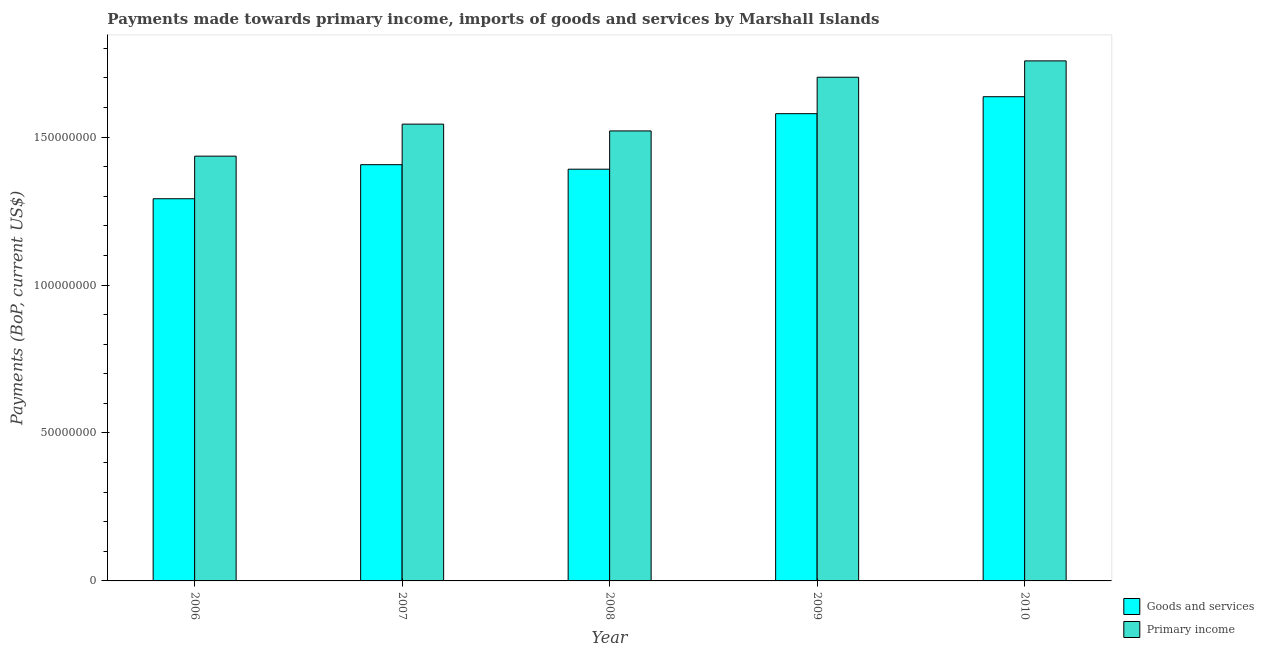How many different coloured bars are there?
Give a very brief answer. 2. How many groups of bars are there?
Ensure brevity in your answer.  5. Are the number of bars per tick equal to the number of legend labels?
Your answer should be compact. Yes. Are the number of bars on each tick of the X-axis equal?
Ensure brevity in your answer.  Yes. How many bars are there on the 1st tick from the left?
Provide a short and direct response. 2. How many bars are there on the 2nd tick from the right?
Your response must be concise. 2. What is the label of the 4th group of bars from the left?
Ensure brevity in your answer.  2009. In how many cases, is the number of bars for a given year not equal to the number of legend labels?
Your response must be concise. 0. What is the payments made towards primary income in 2007?
Offer a very short reply. 1.54e+08. Across all years, what is the maximum payments made towards goods and services?
Provide a short and direct response. 1.64e+08. Across all years, what is the minimum payments made towards goods and services?
Ensure brevity in your answer.  1.29e+08. In which year was the payments made towards goods and services maximum?
Offer a terse response. 2010. What is the total payments made towards goods and services in the graph?
Ensure brevity in your answer.  7.31e+08. What is the difference between the payments made towards goods and services in 2006 and that in 2010?
Ensure brevity in your answer.  -3.45e+07. What is the difference between the payments made towards goods and services in 2009 and the payments made towards primary income in 2008?
Your response must be concise. 1.88e+07. What is the average payments made towards primary income per year?
Provide a short and direct response. 1.59e+08. In the year 2007, what is the difference between the payments made towards goods and services and payments made towards primary income?
Your answer should be very brief. 0. In how many years, is the payments made towards goods and services greater than 40000000 US$?
Make the answer very short. 5. What is the ratio of the payments made towards primary income in 2008 to that in 2009?
Make the answer very short. 0.89. Is the payments made towards goods and services in 2006 less than that in 2010?
Your answer should be compact. Yes. Is the difference between the payments made towards goods and services in 2007 and 2010 greater than the difference between the payments made towards primary income in 2007 and 2010?
Provide a short and direct response. No. What is the difference between the highest and the second highest payments made towards goods and services?
Provide a succinct answer. 5.73e+06. What is the difference between the highest and the lowest payments made towards goods and services?
Provide a succinct answer. 3.45e+07. What does the 2nd bar from the left in 2006 represents?
Make the answer very short. Primary income. What does the 2nd bar from the right in 2008 represents?
Your response must be concise. Goods and services. How many bars are there?
Your response must be concise. 10. How many years are there in the graph?
Your response must be concise. 5. What is the difference between two consecutive major ticks on the Y-axis?
Your answer should be very brief. 5.00e+07. Are the values on the major ticks of Y-axis written in scientific E-notation?
Your response must be concise. No. Does the graph contain grids?
Ensure brevity in your answer.  No. How many legend labels are there?
Make the answer very short. 2. What is the title of the graph?
Offer a terse response. Payments made towards primary income, imports of goods and services by Marshall Islands. Does "Taxes on exports" appear as one of the legend labels in the graph?
Provide a short and direct response. No. What is the label or title of the Y-axis?
Your answer should be very brief. Payments (BoP, current US$). What is the Payments (BoP, current US$) in Goods and services in 2006?
Your response must be concise. 1.29e+08. What is the Payments (BoP, current US$) in Primary income in 2006?
Keep it short and to the point. 1.44e+08. What is the Payments (BoP, current US$) in Goods and services in 2007?
Your response must be concise. 1.41e+08. What is the Payments (BoP, current US$) of Primary income in 2007?
Keep it short and to the point. 1.54e+08. What is the Payments (BoP, current US$) in Goods and services in 2008?
Ensure brevity in your answer.  1.39e+08. What is the Payments (BoP, current US$) in Primary income in 2008?
Ensure brevity in your answer.  1.52e+08. What is the Payments (BoP, current US$) of Goods and services in 2009?
Your answer should be compact. 1.58e+08. What is the Payments (BoP, current US$) in Primary income in 2009?
Provide a succinct answer. 1.70e+08. What is the Payments (BoP, current US$) of Goods and services in 2010?
Ensure brevity in your answer.  1.64e+08. What is the Payments (BoP, current US$) in Primary income in 2010?
Your response must be concise. 1.76e+08. Across all years, what is the maximum Payments (BoP, current US$) of Goods and services?
Your answer should be compact. 1.64e+08. Across all years, what is the maximum Payments (BoP, current US$) of Primary income?
Make the answer very short. 1.76e+08. Across all years, what is the minimum Payments (BoP, current US$) of Goods and services?
Ensure brevity in your answer.  1.29e+08. Across all years, what is the minimum Payments (BoP, current US$) in Primary income?
Offer a very short reply. 1.44e+08. What is the total Payments (BoP, current US$) of Goods and services in the graph?
Give a very brief answer. 7.31e+08. What is the total Payments (BoP, current US$) in Primary income in the graph?
Make the answer very short. 7.96e+08. What is the difference between the Payments (BoP, current US$) in Goods and services in 2006 and that in 2007?
Keep it short and to the point. -1.15e+07. What is the difference between the Payments (BoP, current US$) of Primary income in 2006 and that in 2007?
Provide a succinct answer. -1.08e+07. What is the difference between the Payments (BoP, current US$) in Goods and services in 2006 and that in 2008?
Your response must be concise. -9.99e+06. What is the difference between the Payments (BoP, current US$) of Primary income in 2006 and that in 2008?
Your answer should be very brief. -8.53e+06. What is the difference between the Payments (BoP, current US$) in Goods and services in 2006 and that in 2009?
Your answer should be compact. -2.88e+07. What is the difference between the Payments (BoP, current US$) in Primary income in 2006 and that in 2009?
Provide a succinct answer. -2.67e+07. What is the difference between the Payments (BoP, current US$) in Goods and services in 2006 and that in 2010?
Offer a terse response. -3.45e+07. What is the difference between the Payments (BoP, current US$) in Primary income in 2006 and that in 2010?
Give a very brief answer. -3.22e+07. What is the difference between the Payments (BoP, current US$) in Goods and services in 2007 and that in 2008?
Provide a succinct answer. 1.53e+06. What is the difference between the Payments (BoP, current US$) in Primary income in 2007 and that in 2008?
Keep it short and to the point. 2.30e+06. What is the difference between the Payments (BoP, current US$) in Goods and services in 2007 and that in 2009?
Provide a short and direct response. -1.72e+07. What is the difference between the Payments (BoP, current US$) in Primary income in 2007 and that in 2009?
Your response must be concise. -1.59e+07. What is the difference between the Payments (BoP, current US$) of Goods and services in 2007 and that in 2010?
Ensure brevity in your answer.  -2.30e+07. What is the difference between the Payments (BoP, current US$) of Primary income in 2007 and that in 2010?
Provide a succinct answer. -2.14e+07. What is the difference between the Payments (BoP, current US$) of Goods and services in 2008 and that in 2009?
Your response must be concise. -1.88e+07. What is the difference between the Payments (BoP, current US$) in Primary income in 2008 and that in 2009?
Provide a short and direct response. -1.81e+07. What is the difference between the Payments (BoP, current US$) in Goods and services in 2008 and that in 2010?
Offer a terse response. -2.45e+07. What is the difference between the Payments (BoP, current US$) of Primary income in 2008 and that in 2010?
Your response must be concise. -2.37e+07. What is the difference between the Payments (BoP, current US$) of Goods and services in 2009 and that in 2010?
Provide a short and direct response. -5.73e+06. What is the difference between the Payments (BoP, current US$) of Primary income in 2009 and that in 2010?
Provide a succinct answer. -5.53e+06. What is the difference between the Payments (BoP, current US$) in Goods and services in 2006 and the Payments (BoP, current US$) in Primary income in 2007?
Provide a short and direct response. -2.52e+07. What is the difference between the Payments (BoP, current US$) in Goods and services in 2006 and the Payments (BoP, current US$) in Primary income in 2008?
Keep it short and to the point. -2.29e+07. What is the difference between the Payments (BoP, current US$) of Goods and services in 2006 and the Payments (BoP, current US$) of Primary income in 2009?
Provide a short and direct response. -4.11e+07. What is the difference between the Payments (BoP, current US$) in Goods and services in 2006 and the Payments (BoP, current US$) in Primary income in 2010?
Your response must be concise. -4.66e+07. What is the difference between the Payments (BoP, current US$) of Goods and services in 2007 and the Payments (BoP, current US$) of Primary income in 2008?
Make the answer very short. -1.14e+07. What is the difference between the Payments (BoP, current US$) of Goods and services in 2007 and the Payments (BoP, current US$) of Primary income in 2009?
Ensure brevity in your answer.  -2.96e+07. What is the difference between the Payments (BoP, current US$) of Goods and services in 2007 and the Payments (BoP, current US$) of Primary income in 2010?
Provide a succinct answer. -3.51e+07. What is the difference between the Payments (BoP, current US$) in Goods and services in 2008 and the Payments (BoP, current US$) in Primary income in 2009?
Your answer should be very brief. -3.11e+07. What is the difference between the Payments (BoP, current US$) in Goods and services in 2008 and the Payments (BoP, current US$) in Primary income in 2010?
Make the answer very short. -3.66e+07. What is the difference between the Payments (BoP, current US$) of Goods and services in 2009 and the Payments (BoP, current US$) of Primary income in 2010?
Offer a very short reply. -1.78e+07. What is the average Payments (BoP, current US$) in Goods and services per year?
Your response must be concise. 1.46e+08. What is the average Payments (BoP, current US$) in Primary income per year?
Give a very brief answer. 1.59e+08. In the year 2006, what is the difference between the Payments (BoP, current US$) in Goods and services and Payments (BoP, current US$) in Primary income?
Provide a succinct answer. -1.44e+07. In the year 2007, what is the difference between the Payments (BoP, current US$) of Goods and services and Payments (BoP, current US$) of Primary income?
Offer a very short reply. -1.37e+07. In the year 2008, what is the difference between the Payments (BoP, current US$) of Goods and services and Payments (BoP, current US$) of Primary income?
Ensure brevity in your answer.  -1.29e+07. In the year 2009, what is the difference between the Payments (BoP, current US$) in Goods and services and Payments (BoP, current US$) in Primary income?
Keep it short and to the point. -1.23e+07. In the year 2010, what is the difference between the Payments (BoP, current US$) in Goods and services and Payments (BoP, current US$) in Primary income?
Provide a short and direct response. -1.21e+07. What is the ratio of the Payments (BoP, current US$) in Goods and services in 2006 to that in 2007?
Provide a succinct answer. 0.92. What is the ratio of the Payments (BoP, current US$) in Primary income in 2006 to that in 2007?
Your answer should be compact. 0.93. What is the ratio of the Payments (BoP, current US$) in Goods and services in 2006 to that in 2008?
Your answer should be compact. 0.93. What is the ratio of the Payments (BoP, current US$) in Primary income in 2006 to that in 2008?
Provide a succinct answer. 0.94. What is the ratio of the Payments (BoP, current US$) in Goods and services in 2006 to that in 2009?
Offer a terse response. 0.82. What is the ratio of the Payments (BoP, current US$) of Primary income in 2006 to that in 2009?
Your response must be concise. 0.84. What is the ratio of the Payments (BoP, current US$) in Goods and services in 2006 to that in 2010?
Make the answer very short. 0.79. What is the ratio of the Payments (BoP, current US$) of Primary income in 2006 to that in 2010?
Offer a very short reply. 0.82. What is the ratio of the Payments (BoP, current US$) in Goods and services in 2007 to that in 2008?
Provide a succinct answer. 1.01. What is the ratio of the Payments (BoP, current US$) in Primary income in 2007 to that in 2008?
Your response must be concise. 1.02. What is the ratio of the Payments (BoP, current US$) in Goods and services in 2007 to that in 2009?
Your answer should be compact. 0.89. What is the ratio of the Payments (BoP, current US$) in Primary income in 2007 to that in 2009?
Ensure brevity in your answer.  0.91. What is the ratio of the Payments (BoP, current US$) of Goods and services in 2007 to that in 2010?
Offer a very short reply. 0.86. What is the ratio of the Payments (BoP, current US$) in Primary income in 2007 to that in 2010?
Keep it short and to the point. 0.88. What is the ratio of the Payments (BoP, current US$) of Goods and services in 2008 to that in 2009?
Your answer should be compact. 0.88. What is the ratio of the Payments (BoP, current US$) of Primary income in 2008 to that in 2009?
Keep it short and to the point. 0.89. What is the ratio of the Payments (BoP, current US$) in Goods and services in 2008 to that in 2010?
Give a very brief answer. 0.85. What is the ratio of the Payments (BoP, current US$) of Primary income in 2008 to that in 2010?
Ensure brevity in your answer.  0.87. What is the ratio of the Payments (BoP, current US$) of Goods and services in 2009 to that in 2010?
Ensure brevity in your answer.  0.96. What is the ratio of the Payments (BoP, current US$) of Primary income in 2009 to that in 2010?
Your answer should be very brief. 0.97. What is the difference between the highest and the second highest Payments (BoP, current US$) in Goods and services?
Your answer should be compact. 5.73e+06. What is the difference between the highest and the second highest Payments (BoP, current US$) in Primary income?
Your answer should be very brief. 5.53e+06. What is the difference between the highest and the lowest Payments (BoP, current US$) of Goods and services?
Ensure brevity in your answer.  3.45e+07. What is the difference between the highest and the lowest Payments (BoP, current US$) in Primary income?
Your answer should be very brief. 3.22e+07. 